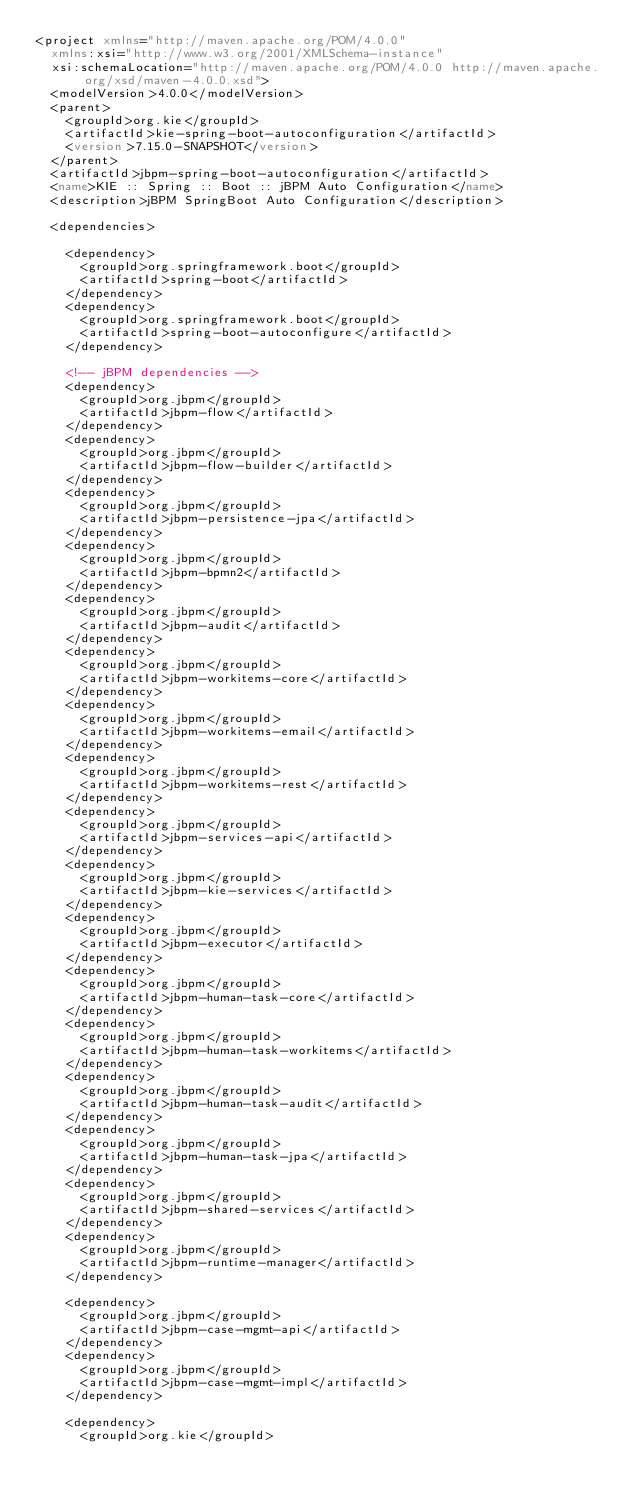Convert code to text. <code><loc_0><loc_0><loc_500><loc_500><_XML_><project xmlns="http://maven.apache.org/POM/4.0.0"
  xmlns:xsi="http://www.w3.org/2001/XMLSchema-instance"
  xsi:schemaLocation="http://maven.apache.org/POM/4.0.0 http://maven.apache.org/xsd/maven-4.0.0.xsd">
  <modelVersion>4.0.0</modelVersion>
  <parent>
    <groupId>org.kie</groupId>
    <artifactId>kie-spring-boot-autoconfiguration</artifactId>
    <version>7.15.0-SNAPSHOT</version>
  </parent>
  <artifactId>jbpm-spring-boot-autoconfiguration</artifactId>
  <name>KIE :: Spring :: Boot :: jBPM Auto Configuration</name>
  <description>jBPM SpringBoot Auto Configuration</description>

  <dependencies>

    <dependency>
      <groupId>org.springframework.boot</groupId>
      <artifactId>spring-boot</artifactId>
    </dependency>
    <dependency>
      <groupId>org.springframework.boot</groupId>
      <artifactId>spring-boot-autoconfigure</artifactId>
    </dependency>

    <!-- jBPM dependencies -->
    <dependency>
      <groupId>org.jbpm</groupId>
      <artifactId>jbpm-flow</artifactId>
    </dependency>
    <dependency>
      <groupId>org.jbpm</groupId>
      <artifactId>jbpm-flow-builder</artifactId>
    </dependency>
    <dependency>
      <groupId>org.jbpm</groupId>
      <artifactId>jbpm-persistence-jpa</artifactId>
    </dependency>
    <dependency>
      <groupId>org.jbpm</groupId>
      <artifactId>jbpm-bpmn2</artifactId>
    </dependency>
    <dependency>
      <groupId>org.jbpm</groupId>
      <artifactId>jbpm-audit</artifactId>
    </dependency>
    <dependency>
      <groupId>org.jbpm</groupId>
      <artifactId>jbpm-workitems-core</artifactId>
    </dependency>
    <dependency>
      <groupId>org.jbpm</groupId>
      <artifactId>jbpm-workitems-email</artifactId>
    </dependency>
    <dependency>
      <groupId>org.jbpm</groupId>
      <artifactId>jbpm-workitems-rest</artifactId>
    </dependency>
    <dependency>
      <groupId>org.jbpm</groupId>
      <artifactId>jbpm-services-api</artifactId>
    </dependency>
    <dependency>
      <groupId>org.jbpm</groupId>
      <artifactId>jbpm-kie-services</artifactId>
    </dependency>
    <dependency>
      <groupId>org.jbpm</groupId>
      <artifactId>jbpm-executor</artifactId>
    </dependency>
    <dependency>
      <groupId>org.jbpm</groupId>
      <artifactId>jbpm-human-task-core</artifactId>
    </dependency>
    <dependency>
      <groupId>org.jbpm</groupId>
      <artifactId>jbpm-human-task-workitems</artifactId>
    </dependency>
    <dependency>
      <groupId>org.jbpm</groupId>
      <artifactId>jbpm-human-task-audit</artifactId>
    </dependency>
    <dependency>
      <groupId>org.jbpm</groupId>
      <artifactId>jbpm-human-task-jpa</artifactId>
    </dependency>
    <dependency>
      <groupId>org.jbpm</groupId>
      <artifactId>jbpm-shared-services</artifactId>
    </dependency>
    <dependency>
      <groupId>org.jbpm</groupId>
      <artifactId>jbpm-runtime-manager</artifactId>
    </dependency>

    <dependency>
      <groupId>org.jbpm</groupId>
      <artifactId>jbpm-case-mgmt-api</artifactId>
    </dependency>
    <dependency>
      <groupId>org.jbpm</groupId>
      <artifactId>jbpm-case-mgmt-impl</artifactId>
    </dependency>

    <dependency>
      <groupId>org.kie</groupId></code> 